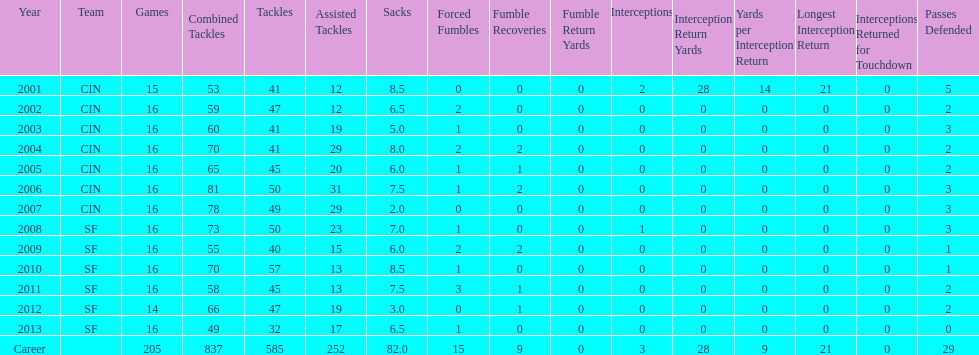What was the total number of fumble recoveries for this player in the year 2004? 2. 